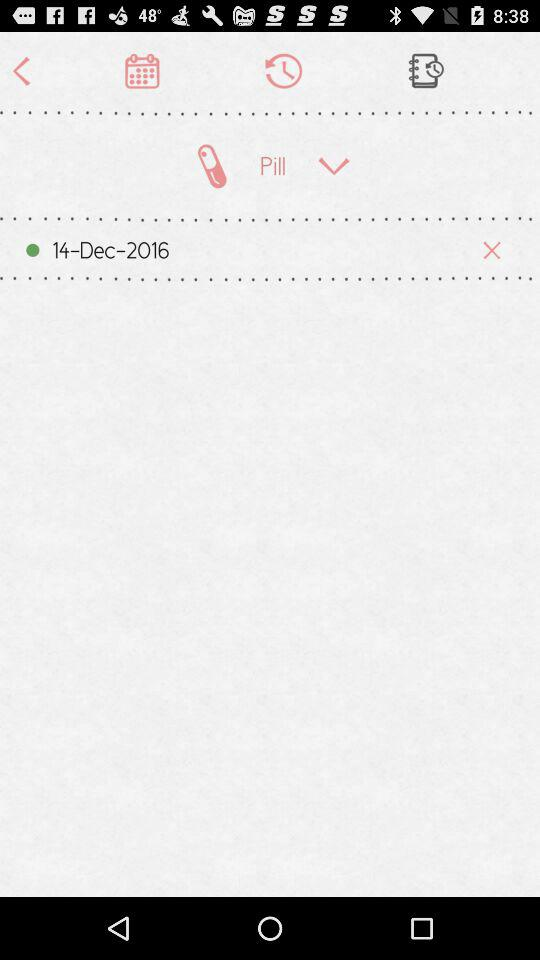What is the important note? The important note is "Use a valid email id". 